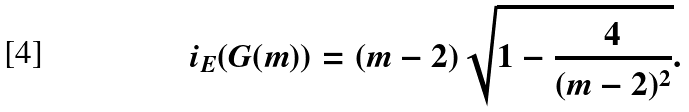<formula> <loc_0><loc_0><loc_500><loc_500>i _ { E } ( G ( m ) ) = ( m - 2 ) \sqrt { 1 - \frac { 4 } { ( m - 2 ) ^ { 2 } } } .</formula> 